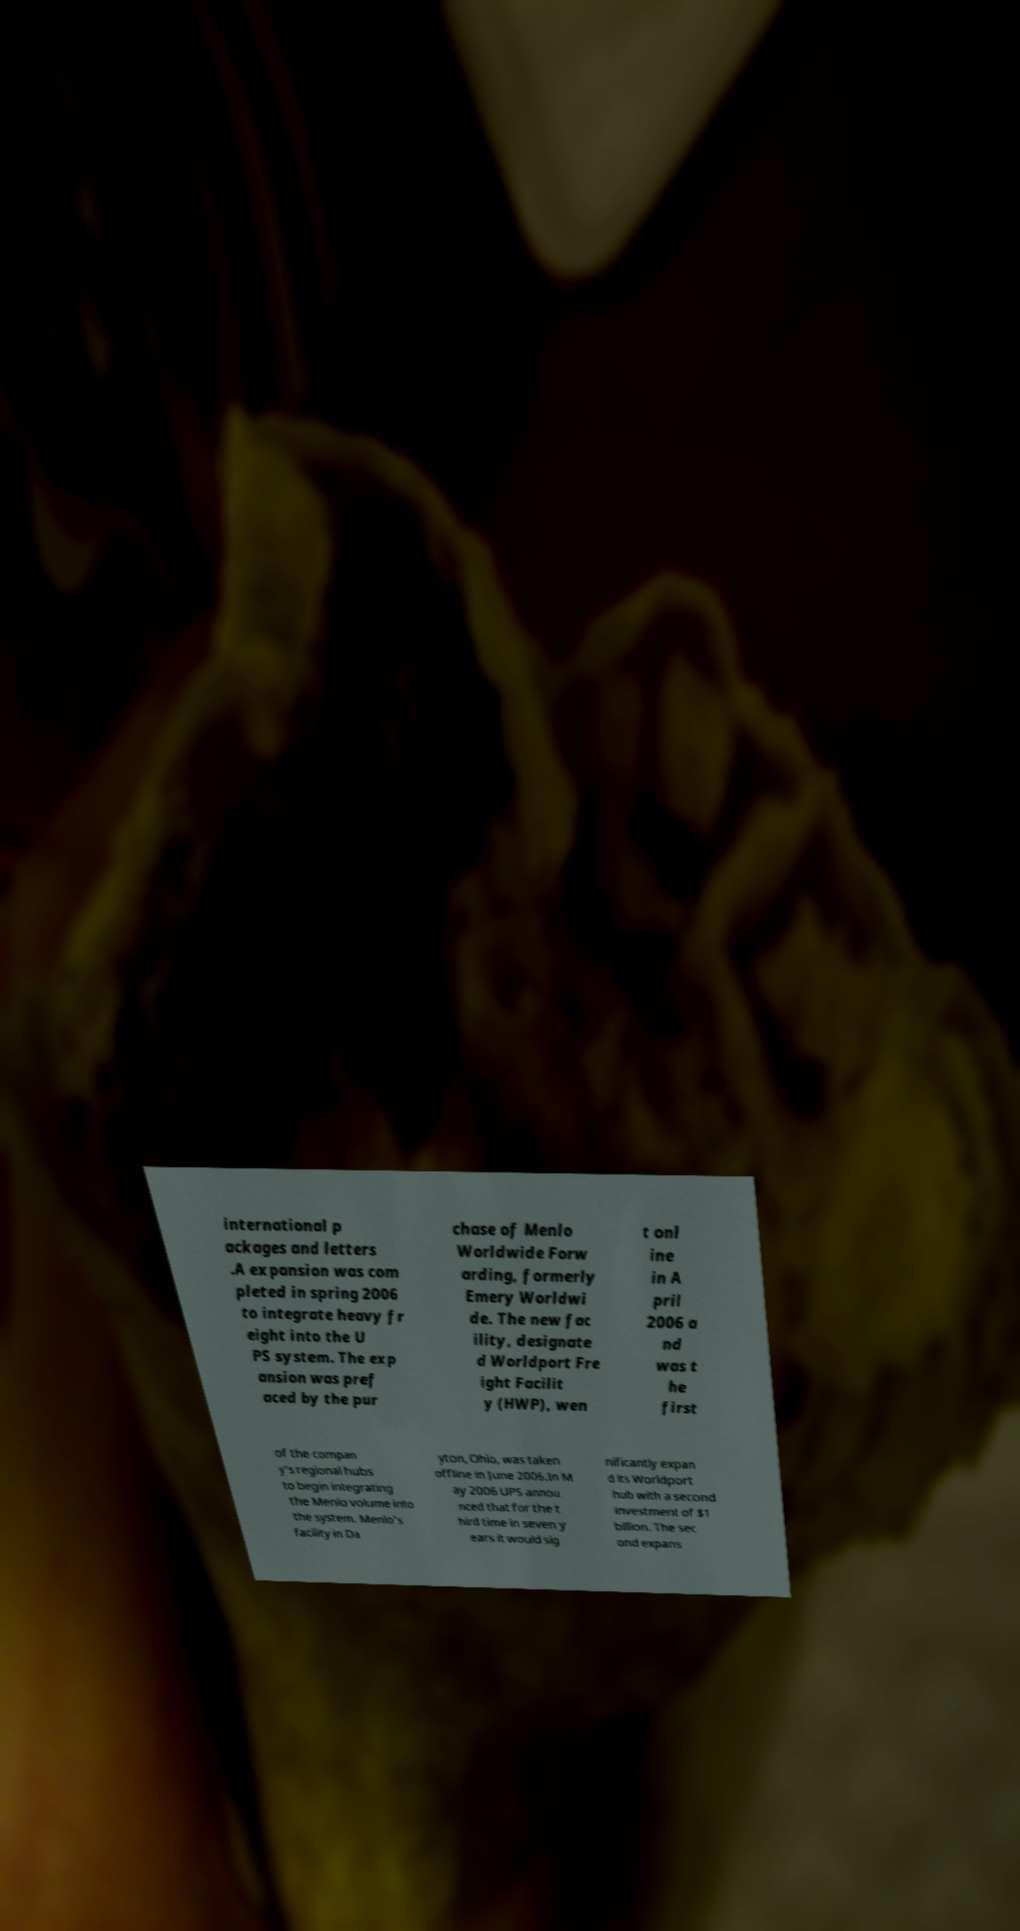I need the written content from this picture converted into text. Can you do that? international p ackages and letters .A expansion was com pleted in spring 2006 to integrate heavy fr eight into the U PS system. The exp ansion was pref aced by the pur chase of Menlo Worldwide Forw arding, formerly Emery Worldwi de. The new fac ility, designate d Worldport Fre ight Facilit y (HWP), wen t onl ine in A pril 2006 a nd was t he first of the compan y's regional hubs to begin integrating the Menlo volume into the system. Menlo's facility in Da yton, Ohio, was taken offline in June 2006.In M ay 2006 UPS annou nced that for the t hird time in seven y ears it would sig nificantly expan d its Worldport hub with a second investment of $1 billion. The sec ond expans 